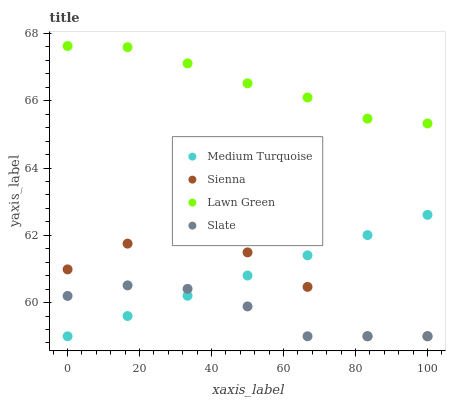Does Slate have the minimum area under the curve?
Answer yes or no. Yes. Does Lawn Green have the maximum area under the curve?
Answer yes or no. Yes. Does Lawn Green have the minimum area under the curve?
Answer yes or no. No. Does Slate have the maximum area under the curve?
Answer yes or no. No. Is Medium Turquoise the smoothest?
Answer yes or no. Yes. Is Sienna the roughest?
Answer yes or no. Yes. Is Lawn Green the smoothest?
Answer yes or no. No. Is Lawn Green the roughest?
Answer yes or no. No. Does Sienna have the lowest value?
Answer yes or no. Yes. Does Lawn Green have the lowest value?
Answer yes or no. No. Does Lawn Green have the highest value?
Answer yes or no. Yes. Does Slate have the highest value?
Answer yes or no. No. Is Slate less than Lawn Green?
Answer yes or no. Yes. Is Lawn Green greater than Sienna?
Answer yes or no. Yes. Does Medium Turquoise intersect Slate?
Answer yes or no. Yes. Is Medium Turquoise less than Slate?
Answer yes or no. No. Is Medium Turquoise greater than Slate?
Answer yes or no. No. Does Slate intersect Lawn Green?
Answer yes or no. No. 